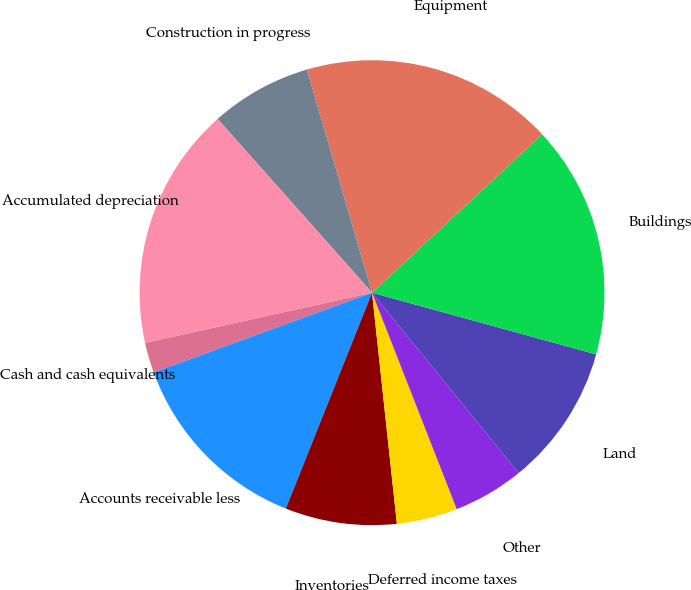<chart> <loc_0><loc_0><loc_500><loc_500><pie_chart><fcel>Cash and cash equivalents<fcel>Accounts receivable less<fcel>Inventories<fcel>Deferred income taxes<fcel>Other<fcel>Land<fcel>Buildings<fcel>Equipment<fcel>Construction in progress<fcel>Accumulated depreciation<nl><fcel>2.11%<fcel>13.38%<fcel>7.75%<fcel>4.23%<fcel>4.93%<fcel>9.86%<fcel>16.2%<fcel>17.6%<fcel>7.04%<fcel>16.9%<nl></chart> 